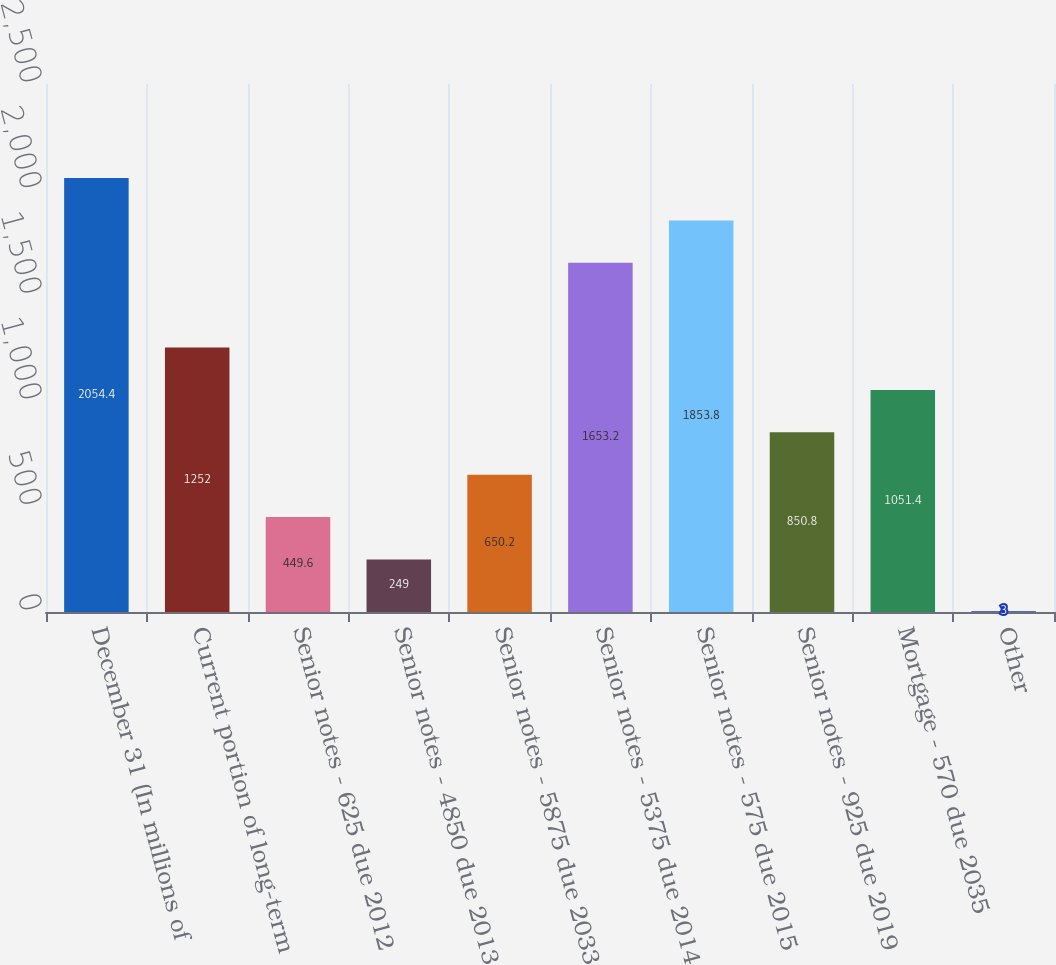Convert chart to OTSL. <chart><loc_0><loc_0><loc_500><loc_500><bar_chart><fcel>December 31 (In millions of<fcel>Current portion of long-term<fcel>Senior notes - 625 due 2012<fcel>Senior notes - 4850 due 2013<fcel>Senior notes - 5875 due 2033<fcel>Senior notes - 5375 due 2014<fcel>Senior notes - 575 due 2015<fcel>Senior notes - 925 due 2019<fcel>Mortgage - 570 due 2035<fcel>Other<nl><fcel>2054.4<fcel>1252<fcel>449.6<fcel>249<fcel>650.2<fcel>1653.2<fcel>1853.8<fcel>850.8<fcel>1051.4<fcel>3<nl></chart> 